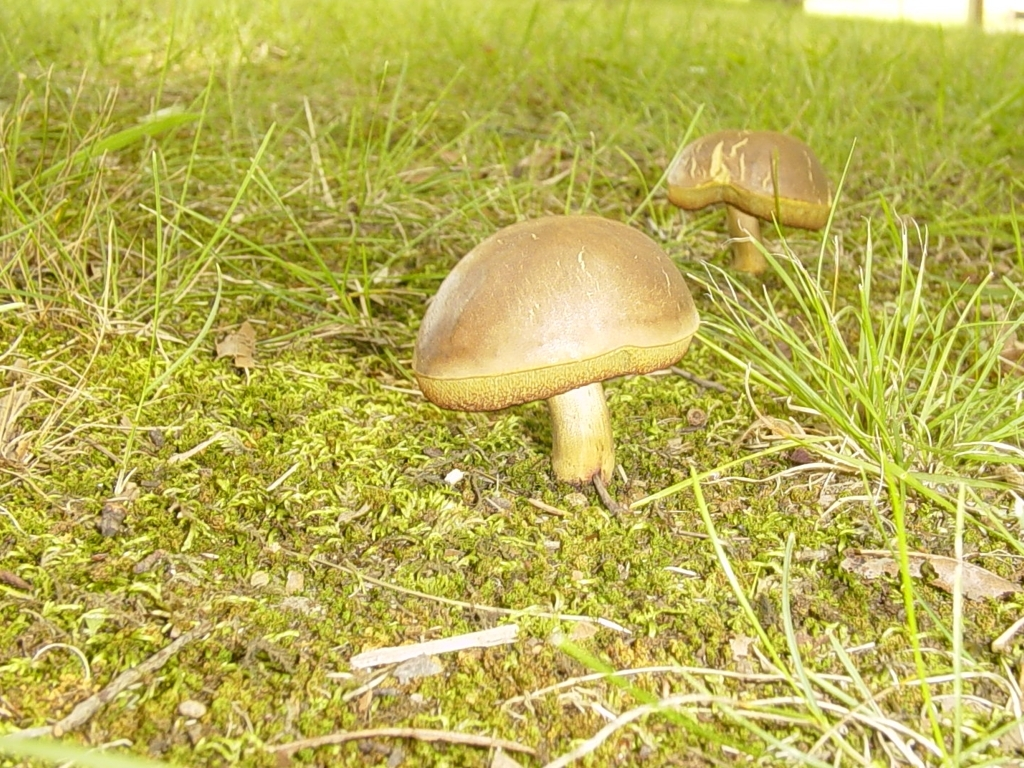What can be said about the focus in the photo? The focus in the photo is executed well. The mushrooms and immediate surrounding area are in sharp detail, highlighting their texture and color, while the background blends softly into the distance, which is a technique often used in photography to draw attention to the subject. 